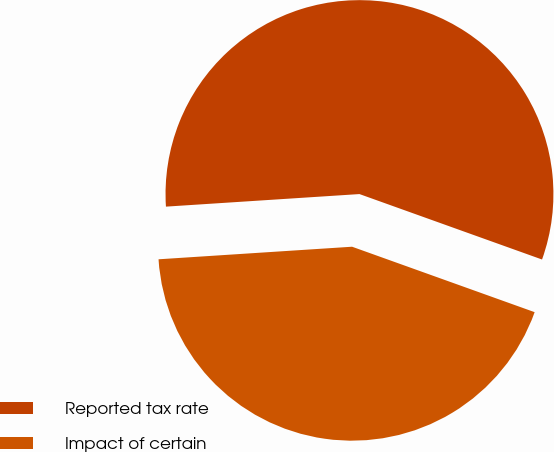<chart> <loc_0><loc_0><loc_500><loc_500><pie_chart><fcel>Reported tax rate<fcel>Impact of certain<nl><fcel>56.51%<fcel>43.49%<nl></chart> 